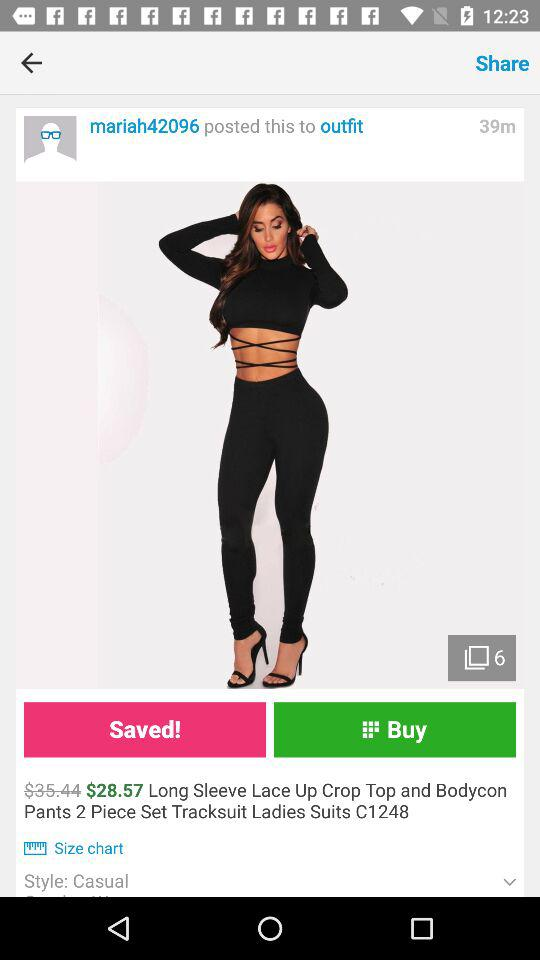Who posted the product post to the "outfit"? The product post to the "outfit" was posted by "mariah42096". 